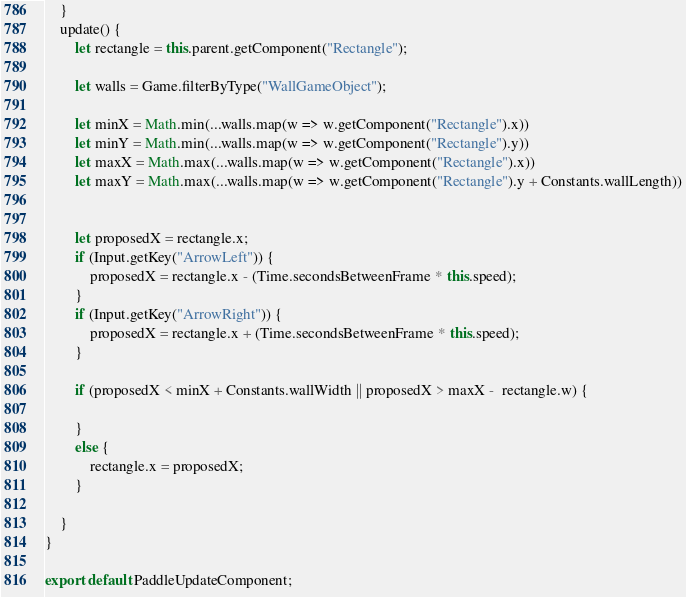Convert code to text. <code><loc_0><loc_0><loc_500><loc_500><_JavaScript_>
    }
    update() {
        let rectangle = this.parent.getComponent("Rectangle");

        let walls = Game.filterByType("WallGameObject");

        let minX = Math.min(...walls.map(w => w.getComponent("Rectangle").x))
        let minY = Math.min(...walls.map(w => w.getComponent("Rectangle").y))
        let maxX = Math.max(...walls.map(w => w.getComponent("Rectangle").x))
        let maxY = Math.max(...walls.map(w => w.getComponent("Rectangle").y + Constants.wallLength))


        let proposedX = rectangle.x;
        if (Input.getKey("ArrowLeft")) {
            proposedX = rectangle.x - (Time.secondsBetweenFrame * this.speed);
        }
        if (Input.getKey("ArrowRight")) {
            proposedX = rectangle.x + (Time.secondsBetweenFrame * this.speed);
        }

        if (proposedX < minX + Constants.wallWidth || proposedX > maxX -  rectangle.w) {

        }
        else {
            rectangle.x = proposedX;
        }

    }
}

export default PaddleUpdateComponent;
</code> 